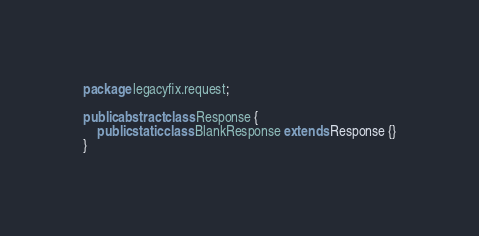<code> <loc_0><loc_0><loc_500><loc_500><_Java_>package legacyfix.request;

public abstract class Response {
	public static class BlankResponse extends Response {}
}
</code> 